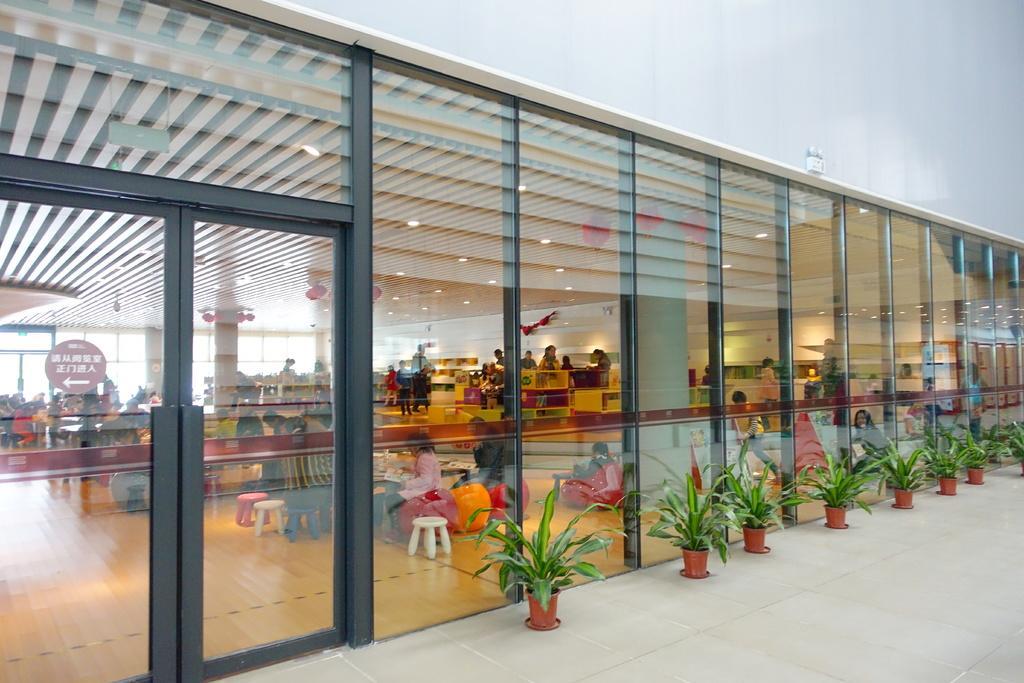Can you describe this image briefly? In this image we can see few potted plants in front of the building, there is a door and through the glasses we can see few people, stools, few objects, lights to the ceiling and a sign board in the building. 